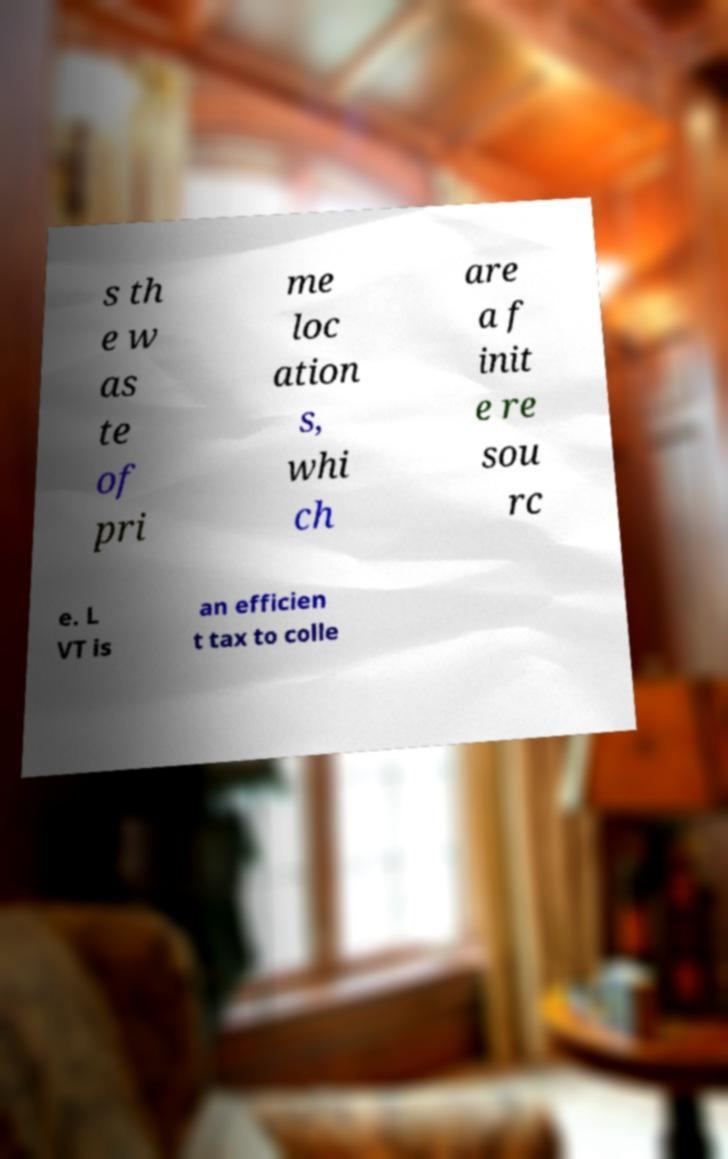What messages or text are displayed in this image? I need them in a readable, typed format. s th e w as te of pri me loc ation s, whi ch are a f init e re sou rc e. L VT is an efficien t tax to colle 